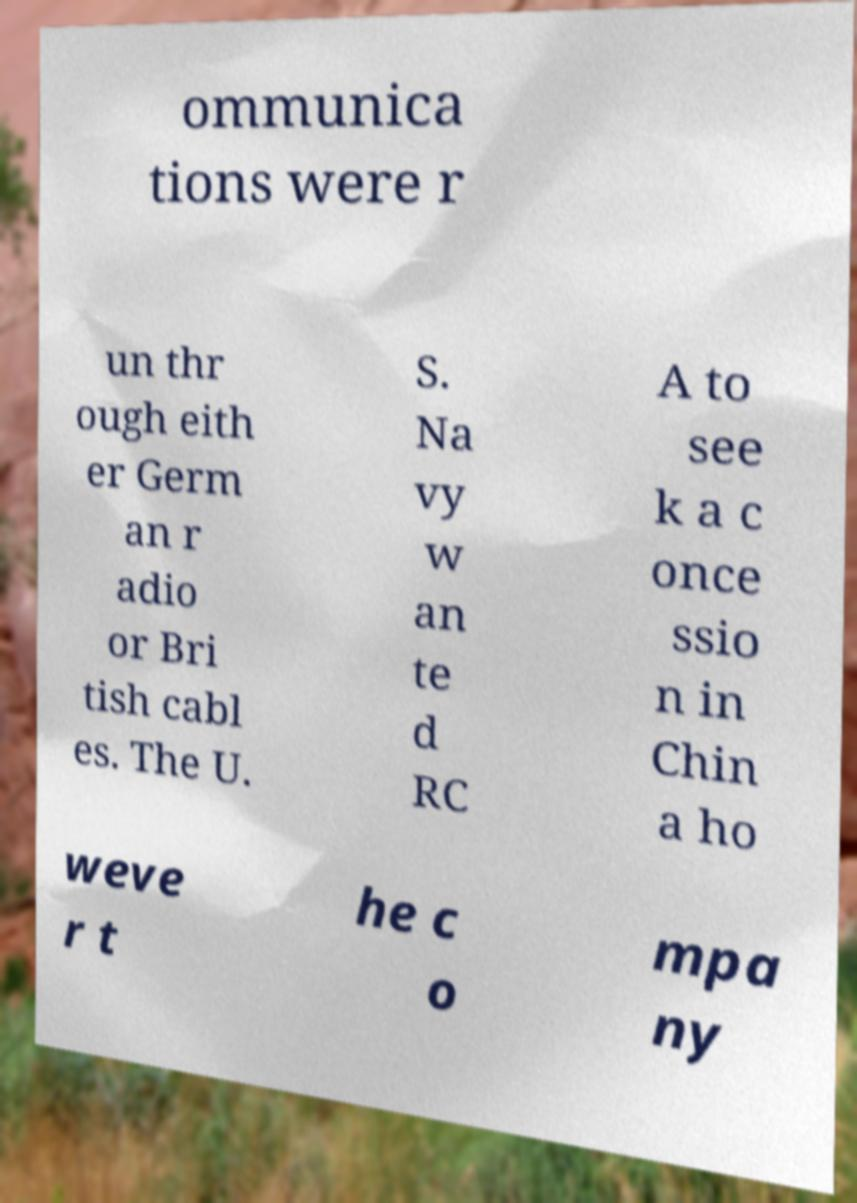There's text embedded in this image that I need extracted. Can you transcribe it verbatim? ommunica tions were r un thr ough eith er Germ an r adio or Bri tish cabl es. The U. S. Na vy w an te d RC A to see k a c once ssio n in Chin a ho weve r t he c o mpa ny 